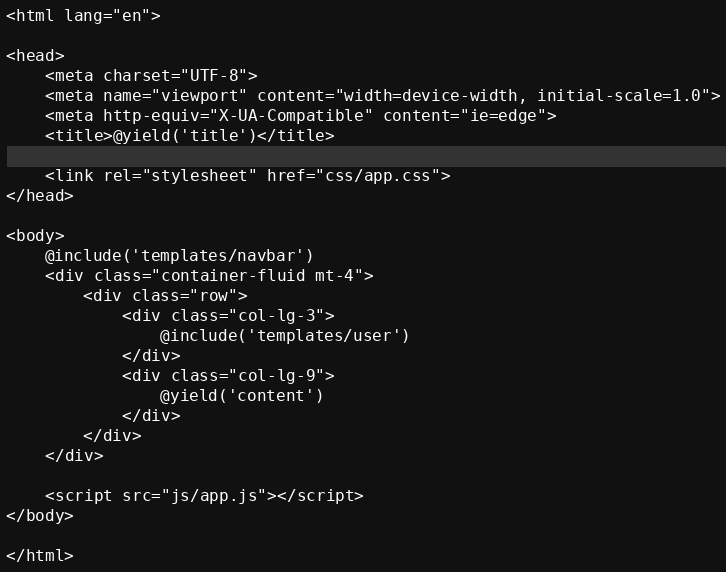<code> <loc_0><loc_0><loc_500><loc_500><_PHP_><html lang="en">

<head>
    <meta charset="UTF-8">
    <meta name="viewport" content="width=device-width, initial-scale=1.0">
    <meta http-equiv="X-UA-Compatible" content="ie=edge">
    <title>@yield('title')</title>

    <link rel="stylesheet" href="css/app.css">
</head>

<body>
    @include('templates/navbar')
    <div class="container-fluid mt-4">
        <div class="row">
            <div class="col-lg-3">
                @include('templates/user')
            </div>
            <div class="col-lg-9">
                @yield('content')
            </div>
        </div>
    </div>
    
    <script src="js/app.js"></script>
</body>

</html>
</code> 